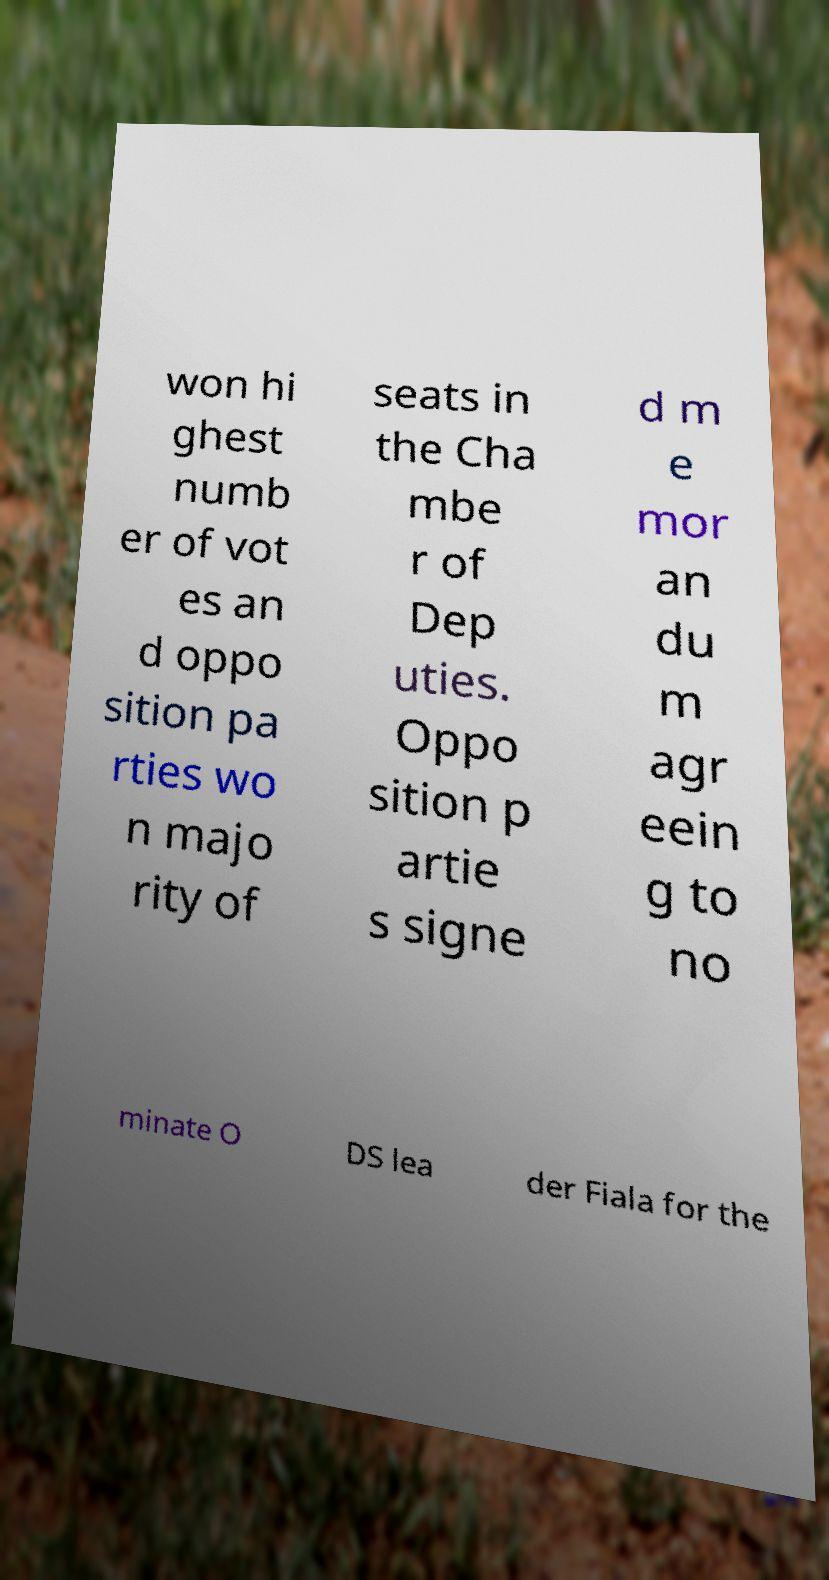What messages or text are displayed in this image? I need them in a readable, typed format. won hi ghest numb er of vot es an d oppo sition pa rties wo n majo rity of seats in the Cha mbe r of Dep uties. Oppo sition p artie s signe d m e mor an du m agr eein g to no minate O DS lea der Fiala for the 